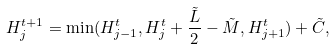<formula> <loc_0><loc_0><loc_500><loc_500>H _ { j } ^ { t + 1 } = \min ( H _ { j - 1 } ^ { t } , H _ { j } ^ { t } + \frac { \tilde { L } } { 2 } - \tilde { M } , H _ { j + 1 } ^ { t } ) + \tilde { C } ,</formula> 